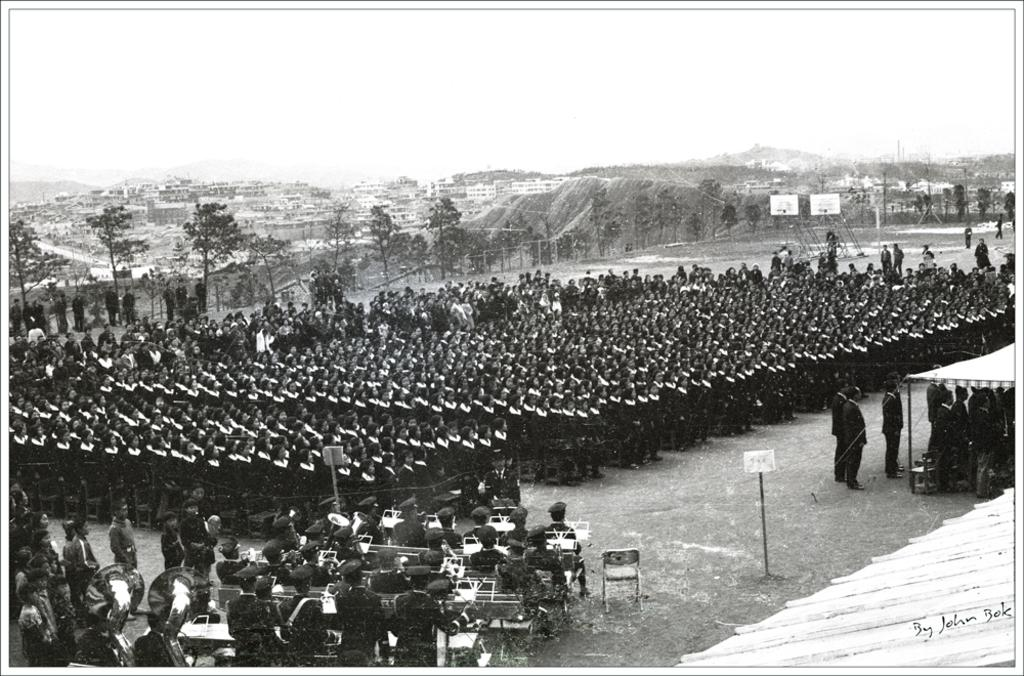What is the main subject of the image? The main subject of the image is a group of people standing. What can be seen in the background of the image? Trees and buildings are visible in the background of the image. Are there any other people in the image besides the standing group? Yes, there are people sitting in front of the group. What is the color scheme of the image? The image is in black and white. What type of paper is being used by the horses in the image? There are no horses present in the image, so there is no paper being used by them. 